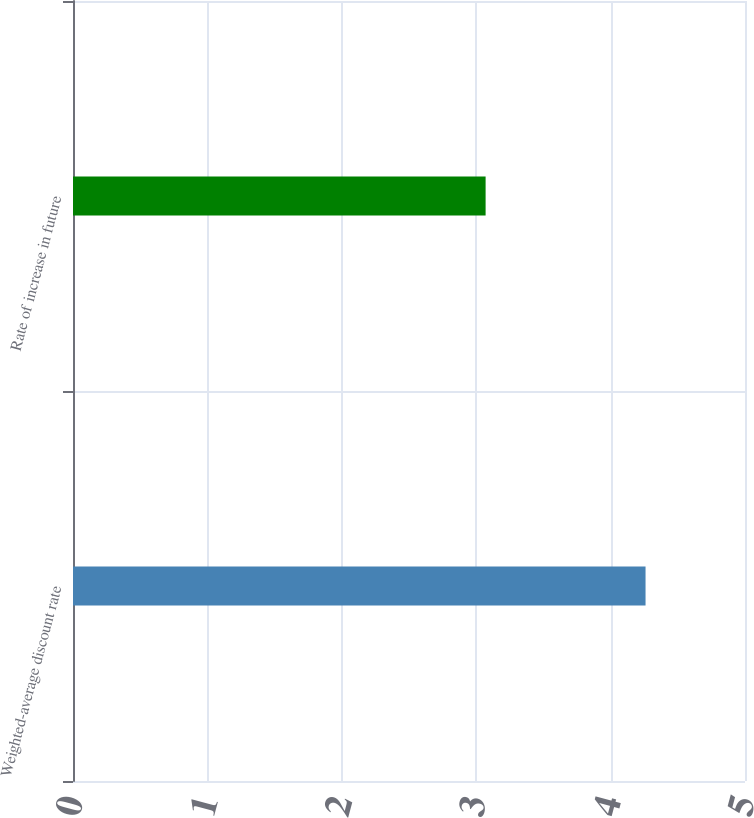<chart> <loc_0><loc_0><loc_500><loc_500><bar_chart><fcel>Weighted-average discount rate<fcel>Rate of increase in future<nl><fcel>4.26<fcel>3.07<nl></chart> 